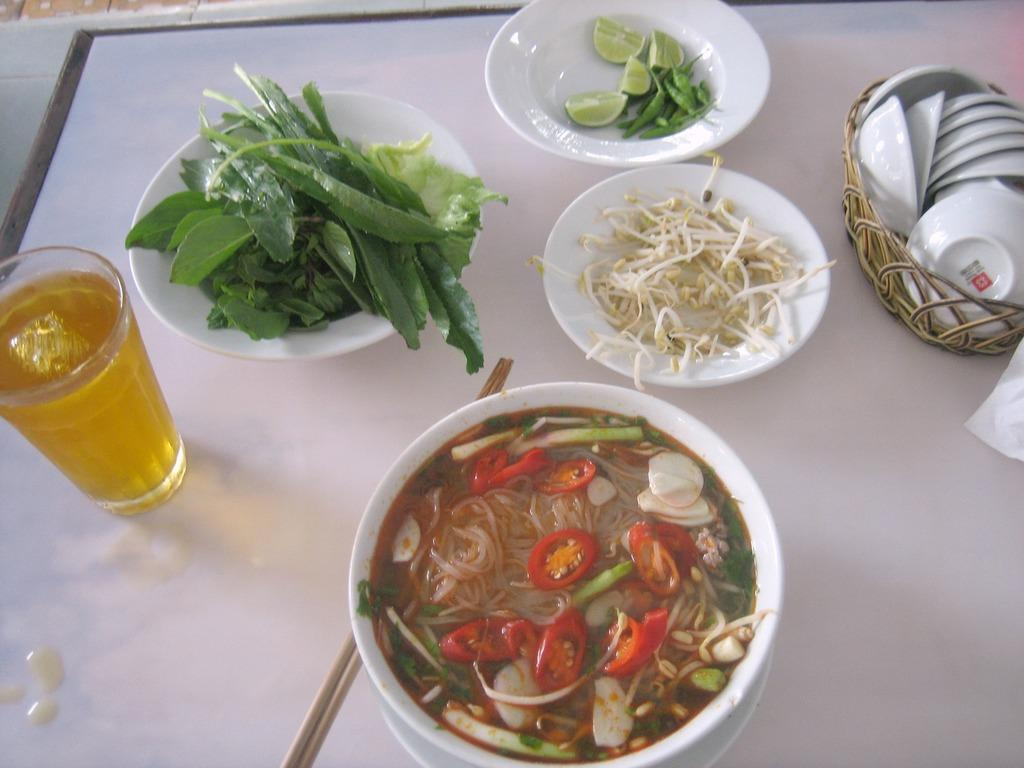What is in the bowl that is visible in the image? There is a bowl of leaves in the image. What is in the other bowl that is visible in the image? There is a bowl of salad in the image. What is on the plate that is visible in the image? There is a plate of lemons in the image. What is in the basket that is visible in the image? There is a basket full of cups in the image. What type of food is visible in the image? There is spaghetti in the image. What is the clear container visible in the image? There is a water glass in the image. What utensil is visible in the image? Chopsticks are visible in the image. What type of statement is being made by the doll in the image? There is no doll present in the image, so no statement can be made by a doll. What type of camp can be seen in the background of the image? There is no camp visible in the image; it features a bowl of leaves, a bowl of salad, a plate of lemons, a basket full of cups, spaghetti, a water glass, and chopsticks. 